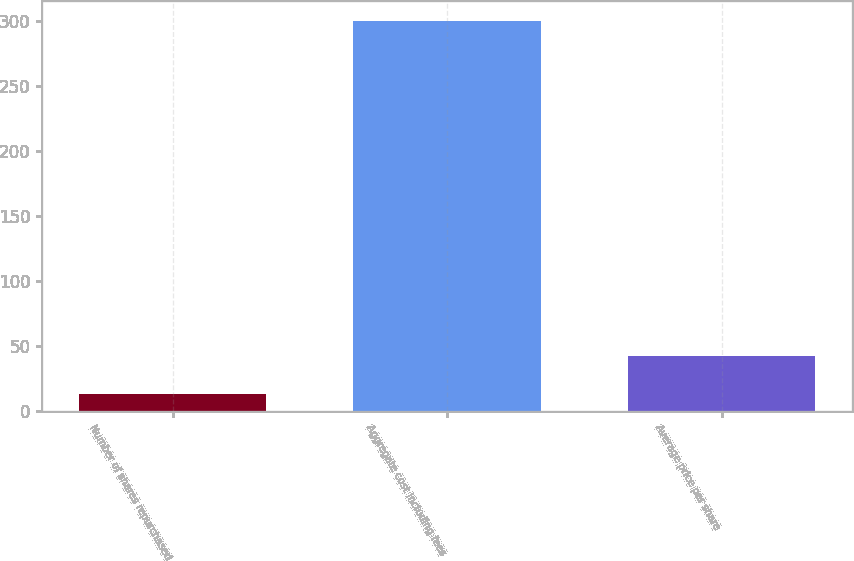Convert chart. <chart><loc_0><loc_0><loc_500><loc_500><bar_chart><fcel>Number of shares repurchased<fcel>Aggregate cost including fees<fcel>Average price per share<nl><fcel>13.7<fcel>300.1<fcel>42.34<nl></chart> 